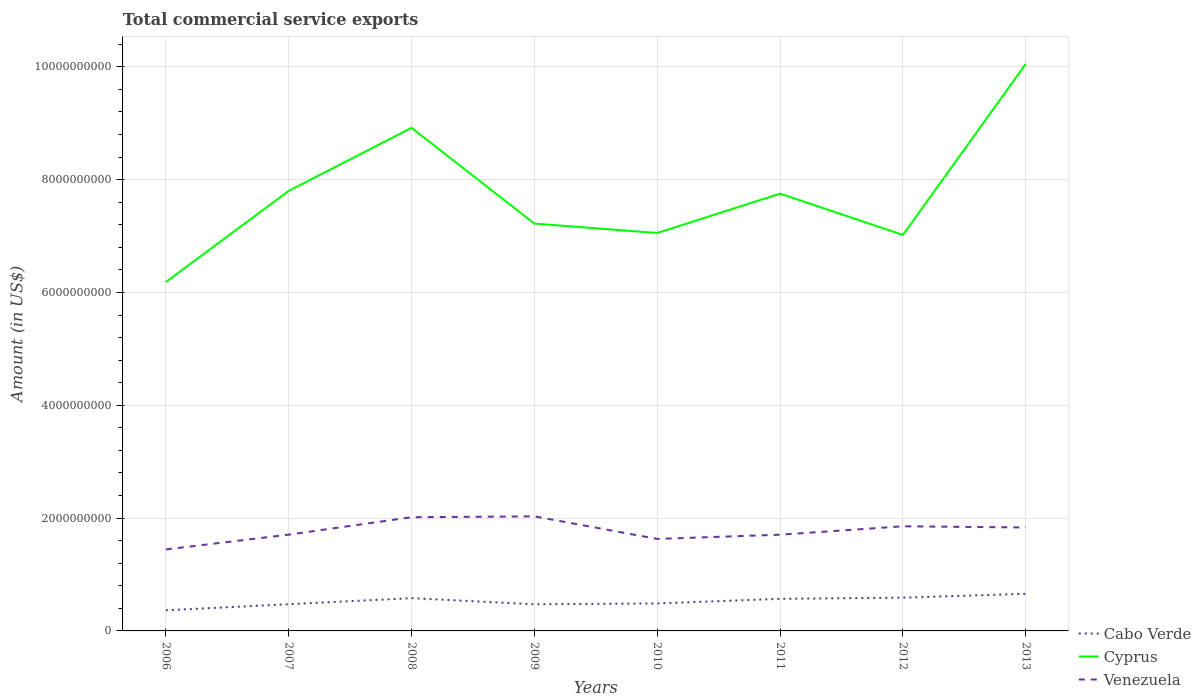Across all years, what is the maximum total commercial service exports in Venezuela?
Your answer should be compact. 1.44e+09. In which year was the total commercial service exports in Venezuela maximum?
Ensure brevity in your answer.  2006. What is the total total commercial service exports in Cabo Verde in the graph?
Your answer should be compact. -6.75e+07. What is the difference between the highest and the second highest total commercial service exports in Venezuela?
Offer a terse response. 5.86e+08. What is the difference between the highest and the lowest total commercial service exports in Cabo Verde?
Keep it short and to the point. 4. How many lines are there?
Make the answer very short. 3. How many years are there in the graph?
Provide a succinct answer. 8. Does the graph contain any zero values?
Your answer should be compact. No. Does the graph contain grids?
Your response must be concise. Yes. How are the legend labels stacked?
Your answer should be very brief. Vertical. What is the title of the graph?
Give a very brief answer. Total commercial service exports. What is the label or title of the Y-axis?
Keep it short and to the point. Amount (in US$). What is the Amount (in US$) in Cabo Verde in 2006?
Your answer should be very brief. 3.66e+08. What is the Amount (in US$) of Cyprus in 2006?
Make the answer very short. 6.19e+09. What is the Amount (in US$) of Venezuela in 2006?
Keep it short and to the point. 1.44e+09. What is the Amount (in US$) of Cabo Verde in 2007?
Your answer should be very brief. 4.74e+08. What is the Amount (in US$) in Cyprus in 2007?
Provide a succinct answer. 7.80e+09. What is the Amount (in US$) in Venezuela in 2007?
Offer a very short reply. 1.71e+09. What is the Amount (in US$) of Cabo Verde in 2008?
Keep it short and to the point. 5.81e+08. What is the Amount (in US$) of Cyprus in 2008?
Your answer should be very brief. 8.92e+09. What is the Amount (in US$) in Venezuela in 2008?
Provide a succinct answer. 2.02e+09. What is the Amount (in US$) in Cabo Verde in 2009?
Provide a short and direct response. 4.72e+08. What is the Amount (in US$) in Cyprus in 2009?
Offer a terse response. 7.22e+09. What is the Amount (in US$) of Venezuela in 2009?
Your answer should be very brief. 2.03e+09. What is the Amount (in US$) of Cabo Verde in 2010?
Provide a succinct answer. 4.87e+08. What is the Amount (in US$) of Cyprus in 2010?
Your response must be concise. 7.05e+09. What is the Amount (in US$) in Venezuela in 2010?
Keep it short and to the point. 1.63e+09. What is the Amount (in US$) of Cabo Verde in 2011?
Ensure brevity in your answer.  5.69e+08. What is the Amount (in US$) in Cyprus in 2011?
Your answer should be compact. 7.75e+09. What is the Amount (in US$) of Venezuela in 2011?
Make the answer very short. 1.71e+09. What is the Amount (in US$) in Cabo Verde in 2012?
Your answer should be compact. 5.90e+08. What is the Amount (in US$) in Cyprus in 2012?
Offer a terse response. 7.02e+09. What is the Amount (in US$) in Venezuela in 2012?
Provide a succinct answer. 1.86e+09. What is the Amount (in US$) in Cabo Verde in 2013?
Your answer should be very brief. 6.58e+08. What is the Amount (in US$) in Cyprus in 2013?
Ensure brevity in your answer.  1.01e+1. What is the Amount (in US$) of Venezuela in 2013?
Your answer should be compact. 1.83e+09. Across all years, what is the maximum Amount (in US$) of Cabo Verde?
Provide a short and direct response. 6.58e+08. Across all years, what is the maximum Amount (in US$) of Cyprus?
Provide a succinct answer. 1.01e+1. Across all years, what is the maximum Amount (in US$) of Venezuela?
Provide a short and direct response. 2.03e+09. Across all years, what is the minimum Amount (in US$) in Cabo Verde?
Offer a terse response. 3.66e+08. Across all years, what is the minimum Amount (in US$) in Cyprus?
Give a very brief answer. 6.19e+09. Across all years, what is the minimum Amount (in US$) of Venezuela?
Give a very brief answer. 1.44e+09. What is the total Amount (in US$) of Cabo Verde in the graph?
Keep it short and to the point. 4.20e+09. What is the total Amount (in US$) of Cyprus in the graph?
Your response must be concise. 6.20e+1. What is the total Amount (in US$) in Venezuela in the graph?
Offer a very short reply. 1.42e+1. What is the difference between the Amount (in US$) in Cabo Verde in 2006 and that in 2007?
Ensure brevity in your answer.  -1.08e+08. What is the difference between the Amount (in US$) of Cyprus in 2006 and that in 2007?
Your answer should be very brief. -1.62e+09. What is the difference between the Amount (in US$) of Venezuela in 2006 and that in 2007?
Keep it short and to the point. -2.62e+08. What is the difference between the Amount (in US$) in Cabo Verde in 2006 and that in 2008?
Offer a very short reply. -2.15e+08. What is the difference between the Amount (in US$) in Cyprus in 2006 and that in 2008?
Your answer should be very brief. -2.73e+09. What is the difference between the Amount (in US$) in Venezuela in 2006 and that in 2008?
Your answer should be very brief. -5.71e+08. What is the difference between the Amount (in US$) of Cabo Verde in 2006 and that in 2009?
Ensure brevity in your answer.  -1.07e+08. What is the difference between the Amount (in US$) in Cyprus in 2006 and that in 2009?
Provide a short and direct response. -1.04e+09. What is the difference between the Amount (in US$) of Venezuela in 2006 and that in 2009?
Your answer should be compact. -5.86e+08. What is the difference between the Amount (in US$) of Cabo Verde in 2006 and that in 2010?
Your answer should be very brief. -1.22e+08. What is the difference between the Amount (in US$) of Cyprus in 2006 and that in 2010?
Your answer should be compact. -8.69e+08. What is the difference between the Amount (in US$) in Venezuela in 2006 and that in 2010?
Ensure brevity in your answer.  -1.86e+08. What is the difference between the Amount (in US$) in Cabo Verde in 2006 and that in 2011?
Offer a very short reply. -2.03e+08. What is the difference between the Amount (in US$) in Cyprus in 2006 and that in 2011?
Keep it short and to the point. -1.57e+09. What is the difference between the Amount (in US$) in Venezuela in 2006 and that in 2011?
Offer a terse response. -2.61e+08. What is the difference between the Amount (in US$) in Cabo Verde in 2006 and that in 2012?
Make the answer very short. -2.24e+08. What is the difference between the Amount (in US$) of Cyprus in 2006 and that in 2012?
Offer a very short reply. -8.35e+08. What is the difference between the Amount (in US$) of Venezuela in 2006 and that in 2012?
Your response must be concise. -4.10e+08. What is the difference between the Amount (in US$) in Cabo Verde in 2006 and that in 2013?
Keep it short and to the point. -2.92e+08. What is the difference between the Amount (in US$) in Cyprus in 2006 and that in 2013?
Make the answer very short. -3.87e+09. What is the difference between the Amount (in US$) in Venezuela in 2006 and that in 2013?
Give a very brief answer. -3.89e+08. What is the difference between the Amount (in US$) in Cabo Verde in 2007 and that in 2008?
Your answer should be compact. -1.07e+08. What is the difference between the Amount (in US$) in Cyprus in 2007 and that in 2008?
Keep it short and to the point. -1.12e+09. What is the difference between the Amount (in US$) in Venezuela in 2007 and that in 2008?
Provide a short and direct response. -3.09e+08. What is the difference between the Amount (in US$) in Cabo Verde in 2007 and that in 2009?
Provide a short and direct response. 1.47e+06. What is the difference between the Amount (in US$) of Cyprus in 2007 and that in 2009?
Provide a succinct answer. 5.80e+08. What is the difference between the Amount (in US$) of Venezuela in 2007 and that in 2009?
Make the answer very short. -3.24e+08. What is the difference between the Amount (in US$) in Cabo Verde in 2007 and that in 2010?
Provide a succinct answer. -1.36e+07. What is the difference between the Amount (in US$) in Cyprus in 2007 and that in 2010?
Ensure brevity in your answer.  7.46e+08. What is the difference between the Amount (in US$) in Venezuela in 2007 and that in 2010?
Make the answer very short. 7.60e+07. What is the difference between the Amount (in US$) of Cabo Verde in 2007 and that in 2011?
Provide a succinct answer. -9.52e+07. What is the difference between the Amount (in US$) of Cyprus in 2007 and that in 2011?
Ensure brevity in your answer.  4.86e+07. What is the difference between the Amount (in US$) of Cabo Verde in 2007 and that in 2012?
Offer a terse response. -1.16e+08. What is the difference between the Amount (in US$) of Cyprus in 2007 and that in 2012?
Keep it short and to the point. 7.81e+08. What is the difference between the Amount (in US$) in Venezuela in 2007 and that in 2012?
Your response must be concise. -1.48e+08. What is the difference between the Amount (in US$) of Cabo Verde in 2007 and that in 2013?
Offer a terse response. -1.84e+08. What is the difference between the Amount (in US$) in Cyprus in 2007 and that in 2013?
Provide a short and direct response. -2.25e+09. What is the difference between the Amount (in US$) in Venezuela in 2007 and that in 2013?
Your response must be concise. -1.27e+08. What is the difference between the Amount (in US$) of Cabo Verde in 2008 and that in 2009?
Your response must be concise. 1.09e+08. What is the difference between the Amount (in US$) in Cyprus in 2008 and that in 2009?
Ensure brevity in your answer.  1.70e+09. What is the difference between the Amount (in US$) in Venezuela in 2008 and that in 2009?
Keep it short and to the point. -1.50e+07. What is the difference between the Amount (in US$) in Cabo Verde in 2008 and that in 2010?
Your response must be concise. 9.37e+07. What is the difference between the Amount (in US$) of Cyprus in 2008 and that in 2010?
Provide a succinct answer. 1.86e+09. What is the difference between the Amount (in US$) of Venezuela in 2008 and that in 2010?
Keep it short and to the point. 3.85e+08. What is the difference between the Amount (in US$) of Cabo Verde in 2008 and that in 2011?
Give a very brief answer. 1.21e+07. What is the difference between the Amount (in US$) in Cyprus in 2008 and that in 2011?
Make the answer very short. 1.17e+09. What is the difference between the Amount (in US$) of Venezuela in 2008 and that in 2011?
Your answer should be compact. 3.10e+08. What is the difference between the Amount (in US$) in Cabo Verde in 2008 and that in 2012?
Ensure brevity in your answer.  -8.97e+06. What is the difference between the Amount (in US$) in Cyprus in 2008 and that in 2012?
Ensure brevity in your answer.  1.90e+09. What is the difference between the Amount (in US$) of Venezuela in 2008 and that in 2012?
Offer a terse response. 1.61e+08. What is the difference between the Amount (in US$) in Cabo Verde in 2008 and that in 2013?
Provide a short and direct response. -7.65e+07. What is the difference between the Amount (in US$) in Cyprus in 2008 and that in 2013?
Give a very brief answer. -1.13e+09. What is the difference between the Amount (in US$) of Venezuela in 2008 and that in 2013?
Your answer should be compact. 1.82e+08. What is the difference between the Amount (in US$) in Cabo Verde in 2009 and that in 2010?
Offer a terse response. -1.51e+07. What is the difference between the Amount (in US$) of Cyprus in 2009 and that in 2010?
Provide a succinct answer. 1.67e+08. What is the difference between the Amount (in US$) in Venezuela in 2009 and that in 2010?
Offer a very short reply. 4.00e+08. What is the difference between the Amount (in US$) of Cabo Verde in 2009 and that in 2011?
Offer a terse response. -9.67e+07. What is the difference between the Amount (in US$) of Cyprus in 2009 and that in 2011?
Provide a short and direct response. -5.31e+08. What is the difference between the Amount (in US$) of Venezuela in 2009 and that in 2011?
Your answer should be compact. 3.25e+08. What is the difference between the Amount (in US$) in Cabo Verde in 2009 and that in 2012?
Your answer should be very brief. -1.18e+08. What is the difference between the Amount (in US$) of Cyprus in 2009 and that in 2012?
Your answer should be very brief. 2.01e+08. What is the difference between the Amount (in US$) of Venezuela in 2009 and that in 2012?
Make the answer very short. 1.76e+08. What is the difference between the Amount (in US$) in Cabo Verde in 2009 and that in 2013?
Provide a succinct answer. -1.85e+08. What is the difference between the Amount (in US$) in Cyprus in 2009 and that in 2013?
Provide a short and direct response. -2.83e+09. What is the difference between the Amount (in US$) of Venezuela in 2009 and that in 2013?
Ensure brevity in your answer.  1.97e+08. What is the difference between the Amount (in US$) in Cabo Verde in 2010 and that in 2011?
Provide a succinct answer. -8.16e+07. What is the difference between the Amount (in US$) of Cyprus in 2010 and that in 2011?
Ensure brevity in your answer.  -6.98e+08. What is the difference between the Amount (in US$) in Venezuela in 2010 and that in 2011?
Provide a succinct answer. -7.50e+07. What is the difference between the Amount (in US$) of Cabo Verde in 2010 and that in 2012?
Keep it short and to the point. -1.03e+08. What is the difference between the Amount (in US$) in Cyprus in 2010 and that in 2012?
Your answer should be compact. 3.44e+07. What is the difference between the Amount (in US$) in Venezuela in 2010 and that in 2012?
Your answer should be very brief. -2.24e+08. What is the difference between the Amount (in US$) in Cabo Verde in 2010 and that in 2013?
Offer a very short reply. -1.70e+08. What is the difference between the Amount (in US$) in Cyprus in 2010 and that in 2013?
Your response must be concise. -3.00e+09. What is the difference between the Amount (in US$) of Venezuela in 2010 and that in 2013?
Make the answer very short. -2.03e+08. What is the difference between the Amount (in US$) of Cabo Verde in 2011 and that in 2012?
Your response must be concise. -2.10e+07. What is the difference between the Amount (in US$) in Cyprus in 2011 and that in 2012?
Your response must be concise. 7.32e+08. What is the difference between the Amount (in US$) of Venezuela in 2011 and that in 2012?
Make the answer very short. -1.49e+08. What is the difference between the Amount (in US$) of Cabo Verde in 2011 and that in 2013?
Make the answer very short. -8.86e+07. What is the difference between the Amount (in US$) in Cyprus in 2011 and that in 2013?
Make the answer very short. -2.30e+09. What is the difference between the Amount (in US$) in Venezuela in 2011 and that in 2013?
Ensure brevity in your answer.  -1.28e+08. What is the difference between the Amount (in US$) in Cabo Verde in 2012 and that in 2013?
Ensure brevity in your answer.  -6.75e+07. What is the difference between the Amount (in US$) in Cyprus in 2012 and that in 2013?
Your response must be concise. -3.03e+09. What is the difference between the Amount (in US$) of Venezuela in 2012 and that in 2013?
Provide a short and direct response. 2.10e+07. What is the difference between the Amount (in US$) of Cabo Verde in 2006 and the Amount (in US$) of Cyprus in 2007?
Give a very brief answer. -7.44e+09. What is the difference between the Amount (in US$) of Cabo Verde in 2006 and the Amount (in US$) of Venezuela in 2007?
Offer a terse response. -1.34e+09. What is the difference between the Amount (in US$) in Cyprus in 2006 and the Amount (in US$) in Venezuela in 2007?
Provide a short and direct response. 4.48e+09. What is the difference between the Amount (in US$) in Cabo Verde in 2006 and the Amount (in US$) in Cyprus in 2008?
Provide a short and direct response. -8.55e+09. What is the difference between the Amount (in US$) in Cabo Verde in 2006 and the Amount (in US$) in Venezuela in 2008?
Offer a terse response. -1.65e+09. What is the difference between the Amount (in US$) of Cyprus in 2006 and the Amount (in US$) of Venezuela in 2008?
Ensure brevity in your answer.  4.17e+09. What is the difference between the Amount (in US$) in Cabo Verde in 2006 and the Amount (in US$) in Cyprus in 2009?
Your response must be concise. -6.86e+09. What is the difference between the Amount (in US$) in Cabo Verde in 2006 and the Amount (in US$) in Venezuela in 2009?
Offer a terse response. -1.67e+09. What is the difference between the Amount (in US$) in Cyprus in 2006 and the Amount (in US$) in Venezuela in 2009?
Ensure brevity in your answer.  4.15e+09. What is the difference between the Amount (in US$) in Cabo Verde in 2006 and the Amount (in US$) in Cyprus in 2010?
Your answer should be compact. -6.69e+09. What is the difference between the Amount (in US$) in Cabo Verde in 2006 and the Amount (in US$) in Venezuela in 2010?
Give a very brief answer. -1.27e+09. What is the difference between the Amount (in US$) of Cyprus in 2006 and the Amount (in US$) of Venezuela in 2010?
Provide a short and direct response. 4.55e+09. What is the difference between the Amount (in US$) in Cabo Verde in 2006 and the Amount (in US$) in Cyprus in 2011?
Offer a very short reply. -7.39e+09. What is the difference between the Amount (in US$) of Cabo Verde in 2006 and the Amount (in US$) of Venezuela in 2011?
Ensure brevity in your answer.  -1.34e+09. What is the difference between the Amount (in US$) in Cyprus in 2006 and the Amount (in US$) in Venezuela in 2011?
Make the answer very short. 4.48e+09. What is the difference between the Amount (in US$) of Cabo Verde in 2006 and the Amount (in US$) of Cyprus in 2012?
Ensure brevity in your answer.  -6.66e+09. What is the difference between the Amount (in US$) in Cabo Verde in 2006 and the Amount (in US$) in Venezuela in 2012?
Offer a very short reply. -1.49e+09. What is the difference between the Amount (in US$) of Cyprus in 2006 and the Amount (in US$) of Venezuela in 2012?
Make the answer very short. 4.33e+09. What is the difference between the Amount (in US$) of Cabo Verde in 2006 and the Amount (in US$) of Cyprus in 2013?
Offer a terse response. -9.69e+09. What is the difference between the Amount (in US$) of Cabo Verde in 2006 and the Amount (in US$) of Venezuela in 2013?
Your answer should be compact. -1.47e+09. What is the difference between the Amount (in US$) of Cyprus in 2006 and the Amount (in US$) of Venezuela in 2013?
Make the answer very short. 4.35e+09. What is the difference between the Amount (in US$) of Cabo Verde in 2007 and the Amount (in US$) of Cyprus in 2008?
Your answer should be very brief. -8.45e+09. What is the difference between the Amount (in US$) of Cabo Verde in 2007 and the Amount (in US$) of Venezuela in 2008?
Make the answer very short. -1.54e+09. What is the difference between the Amount (in US$) in Cyprus in 2007 and the Amount (in US$) in Venezuela in 2008?
Offer a very short reply. 5.79e+09. What is the difference between the Amount (in US$) in Cabo Verde in 2007 and the Amount (in US$) in Cyprus in 2009?
Your response must be concise. -6.75e+09. What is the difference between the Amount (in US$) of Cabo Verde in 2007 and the Amount (in US$) of Venezuela in 2009?
Make the answer very short. -1.56e+09. What is the difference between the Amount (in US$) in Cyprus in 2007 and the Amount (in US$) in Venezuela in 2009?
Offer a terse response. 5.77e+09. What is the difference between the Amount (in US$) in Cabo Verde in 2007 and the Amount (in US$) in Cyprus in 2010?
Your response must be concise. -6.58e+09. What is the difference between the Amount (in US$) of Cabo Verde in 2007 and the Amount (in US$) of Venezuela in 2010?
Keep it short and to the point. -1.16e+09. What is the difference between the Amount (in US$) of Cyprus in 2007 and the Amount (in US$) of Venezuela in 2010?
Keep it short and to the point. 6.17e+09. What is the difference between the Amount (in US$) of Cabo Verde in 2007 and the Amount (in US$) of Cyprus in 2011?
Your answer should be compact. -7.28e+09. What is the difference between the Amount (in US$) of Cabo Verde in 2007 and the Amount (in US$) of Venezuela in 2011?
Ensure brevity in your answer.  -1.23e+09. What is the difference between the Amount (in US$) in Cyprus in 2007 and the Amount (in US$) in Venezuela in 2011?
Give a very brief answer. 6.10e+09. What is the difference between the Amount (in US$) of Cabo Verde in 2007 and the Amount (in US$) of Cyprus in 2012?
Keep it short and to the point. -6.55e+09. What is the difference between the Amount (in US$) of Cabo Verde in 2007 and the Amount (in US$) of Venezuela in 2012?
Your answer should be very brief. -1.38e+09. What is the difference between the Amount (in US$) in Cyprus in 2007 and the Amount (in US$) in Venezuela in 2012?
Your answer should be compact. 5.95e+09. What is the difference between the Amount (in US$) of Cabo Verde in 2007 and the Amount (in US$) of Cyprus in 2013?
Offer a terse response. -9.58e+09. What is the difference between the Amount (in US$) of Cabo Verde in 2007 and the Amount (in US$) of Venezuela in 2013?
Offer a very short reply. -1.36e+09. What is the difference between the Amount (in US$) in Cyprus in 2007 and the Amount (in US$) in Venezuela in 2013?
Your response must be concise. 5.97e+09. What is the difference between the Amount (in US$) of Cabo Verde in 2008 and the Amount (in US$) of Cyprus in 2009?
Offer a very short reply. -6.64e+09. What is the difference between the Amount (in US$) of Cabo Verde in 2008 and the Amount (in US$) of Venezuela in 2009?
Keep it short and to the point. -1.45e+09. What is the difference between the Amount (in US$) in Cyprus in 2008 and the Amount (in US$) in Venezuela in 2009?
Offer a terse response. 6.89e+09. What is the difference between the Amount (in US$) of Cabo Verde in 2008 and the Amount (in US$) of Cyprus in 2010?
Provide a short and direct response. -6.47e+09. What is the difference between the Amount (in US$) of Cabo Verde in 2008 and the Amount (in US$) of Venezuela in 2010?
Your answer should be compact. -1.05e+09. What is the difference between the Amount (in US$) of Cyprus in 2008 and the Amount (in US$) of Venezuela in 2010?
Offer a terse response. 7.29e+09. What is the difference between the Amount (in US$) of Cabo Verde in 2008 and the Amount (in US$) of Cyprus in 2011?
Offer a very short reply. -7.17e+09. What is the difference between the Amount (in US$) of Cabo Verde in 2008 and the Amount (in US$) of Venezuela in 2011?
Provide a succinct answer. -1.12e+09. What is the difference between the Amount (in US$) of Cyprus in 2008 and the Amount (in US$) of Venezuela in 2011?
Offer a terse response. 7.21e+09. What is the difference between the Amount (in US$) in Cabo Verde in 2008 and the Amount (in US$) in Cyprus in 2012?
Ensure brevity in your answer.  -6.44e+09. What is the difference between the Amount (in US$) in Cabo Verde in 2008 and the Amount (in US$) in Venezuela in 2012?
Ensure brevity in your answer.  -1.27e+09. What is the difference between the Amount (in US$) of Cyprus in 2008 and the Amount (in US$) of Venezuela in 2012?
Ensure brevity in your answer.  7.06e+09. What is the difference between the Amount (in US$) of Cabo Verde in 2008 and the Amount (in US$) of Cyprus in 2013?
Keep it short and to the point. -9.47e+09. What is the difference between the Amount (in US$) in Cabo Verde in 2008 and the Amount (in US$) in Venezuela in 2013?
Make the answer very short. -1.25e+09. What is the difference between the Amount (in US$) in Cyprus in 2008 and the Amount (in US$) in Venezuela in 2013?
Provide a short and direct response. 7.08e+09. What is the difference between the Amount (in US$) in Cabo Verde in 2009 and the Amount (in US$) in Cyprus in 2010?
Ensure brevity in your answer.  -6.58e+09. What is the difference between the Amount (in US$) of Cabo Verde in 2009 and the Amount (in US$) of Venezuela in 2010?
Your answer should be compact. -1.16e+09. What is the difference between the Amount (in US$) of Cyprus in 2009 and the Amount (in US$) of Venezuela in 2010?
Your response must be concise. 5.59e+09. What is the difference between the Amount (in US$) of Cabo Verde in 2009 and the Amount (in US$) of Cyprus in 2011?
Your answer should be very brief. -7.28e+09. What is the difference between the Amount (in US$) in Cabo Verde in 2009 and the Amount (in US$) in Venezuela in 2011?
Provide a succinct answer. -1.23e+09. What is the difference between the Amount (in US$) in Cyprus in 2009 and the Amount (in US$) in Venezuela in 2011?
Your answer should be compact. 5.52e+09. What is the difference between the Amount (in US$) of Cabo Verde in 2009 and the Amount (in US$) of Cyprus in 2012?
Ensure brevity in your answer.  -6.55e+09. What is the difference between the Amount (in US$) in Cabo Verde in 2009 and the Amount (in US$) in Venezuela in 2012?
Make the answer very short. -1.38e+09. What is the difference between the Amount (in US$) in Cyprus in 2009 and the Amount (in US$) in Venezuela in 2012?
Your answer should be very brief. 5.37e+09. What is the difference between the Amount (in US$) of Cabo Verde in 2009 and the Amount (in US$) of Cyprus in 2013?
Ensure brevity in your answer.  -9.58e+09. What is the difference between the Amount (in US$) in Cabo Verde in 2009 and the Amount (in US$) in Venezuela in 2013?
Your response must be concise. -1.36e+09. What is the difference between the Amount (in US$) of Cyprus in 2009 and the Amount (in US$) of Venezuela in 2013?
Give a very brief answer. 5.39e+09. What is the difference between the Amount (in US$) of Cabo Verde in 2010 and the Amount (in US$) of Cyprus in 2011?
Your answer should be very brief. -7.27e+09. What is the difference between the Amount (in US$) of Cabo Verde in 2010 and the Amount (in US$) of Venezuela in 2011?
Your response must be concise. -1.22e+09. What is the difference between the Amount (in US$) in Cyprus in 2010 and the Amount (in US$) in Venezuela in 2011?
Make the answer very short. 5.35e+09. What is the difference between the Amount (in US$) in Cabo Verde in 2010 and the Amount (in US$) in Cyprus in 2012?
Offer a very short reply. -6.53e+09. What is the difference between the Amount (in US$) in Cabo Verde in 2010 and the Amount (in US$) in Venezuela in 2012?
Provide a succinct answer. -1.37e+09. What is the difference between the Amount (in US$) in Cyprus in 2010 and the Amount (in US$) in Venezuela in 2012?
Give a very brief answer. 5.20e+09. What is the difference between the Amount (in US$) in Cabo Verde in 2010 and the Amount (in US$) in Cyprus in 2013?
Offer a terse response. -9.57e+09. What is the difference between the Amount (in US$) of Cabo Verde in 2010 and the Amount (in US$) of Venezuela in 2013?
Offer a very short reply. -1.35e+09. What is the difference between the Amount (in US$) in Cyprus in 2010 and the Amount (in US$) in Venezuela in 2013?
Give a very brief answer. 5.22e+09. What is the difference between the Amount (in US$) in Cabo Verde in 2011 and the Amount (in US$) in Cyprus in 2012?
Give a very brief answer. -6.45e+09. What is the difference between the Amount (in US$) of Cabo Verde in 2011 and the Amount (in US$) of Venezuela in 2012?
Ensure brevity in your answer.  -1.29e+09. What is the difference between the Amount (in US$) of Cyprus in 2011 and the Amount (in US$) of Venezuela in 2012?
Make the answer very short. 5.90e+09. What is the difference between the Amount (in US$) of Cabo Verde in 2011 and the Amount (in US$) of Cyprus in 2013?
Your response must be concise. -9.48e+09. What is the difference between the Amount (in US$) of Cabo Verde in 2011 and the Amount (in US$) of Venezuela in 2013?
Make the answer very short. -1.27e+09. What is the difference between the Amount (in US$) of Cyprus in 2011 and the Amount (in US$) of Venezuela in 2013?
Ensure brevity in your answer.  5.92e+09. What is the difference between the Amount (in US$) in Cabo Verde in 2012 and the Amount (in US$) in Cyprus in 2013?
Provide a succinct answer. -9.46e+09. What is the difference between the Amount (in US$) in Cabo Verde in 2012 and the Amount (in US$) in Venezuela in 2013?
Ensure brevity in your answer.  -1.24e+09. What is the difference between the Amount (in US$) of Cyprus in 2012 and the Amount (in US$) of Venezuela in 2013?
Provide a succinct answer. 5.19e+09. What is the average Amount (in US$) of Cabo Verde per year?
Provide a short and direct response. 5.25e+08. What is the average Amount (in US$) of Cyprus per year?
Your answer should be very brief. 7.75e+09. What is the average Amount (in US$) in Venezuela per year?
Make the answer very short. 1.78e+09. In the year 2006, what is the difference between the Amount (in US$) of Cabo Verde and Amount (in US$) of Cyprus?
Ensure brevity in your answer.  -5.82e+09. In the year 2006, what is the difference between the Amount (in US$) in Cabo Verde and Amount (in US$) in Venezuela?
Your answer should be compact. -1.08e+09. In the year 2006, what is the difference between the Amount (in US$) of Cyprus and Amount (in US$) of Venezuela?
Your answer should be very brief. 4.74e+09. In the year 2007, what is the difference between the Amount (in US$) of Cabo Verde and Amount (in US$) of Cyprus?
Ensure brevity in your answer.  -7.33e+09. In the year 2007, what is the difference between the Amount (in US$) in Cabo Verde and Amount (in US$) in Venezuela?
Make the answer very short. -1.23e+09. In the year 2007, what is the difference between the Amount (in US$) in Cyprus and Amount (in US$) in Venezuela?
Your answer should be compact. 6.09e+09. In the year 2008, what is the difference between the Amount (in US$) in Cabo Verde and Amount (in US$) in Cyprus?
Make the answer very short. -8.34e+09. In the year 2008, what is the difference between the Amount (in US$) in Cabo Verde and Amount (in US$) in Venezuela?
Provide a succinct answer. -1.43e+09. In the year 2008, what is the difference between the Amount (in US$) in Cyprus and Amount (in US$) in Venezuela?
Provide a short and direct response. 6.90e+09. In the year 2009, what is the difference between the Amount (in US$) of Cabo Verde and Amount (in US$) of Cyprus?
Your answer should be very brief. -6.75e+09. In the year 2009, what is the difference between the Amount (in US$) in Cabo Verde and Amount (in US$) in Venezuela?
Your response must be concise. -1.56e+09. In the year 2009, what is the difference between the Amount (in US$) in Cyprus and Amount (in US$) in Venezuela?
Provide a short and direct response. 5.19e+09. In the year 2010, what is the difference between the Amount (in US$) in Cabo Verde and Amount (in US$) in Cyprus?
Provide a short and direct response. -6.57e+09. In the year 2010, what is the difference between the Amount (in US$) of Cabo Verde and Amount (in US$) of Venezuela?
Your response must be concise. -1.14e+09. In the year 2010, what is the difference between the Amount (in US$) in Cyprus and Amount (in US$) in Venezuela?
Keep it short and to the point. 5.42e+09. In the year 2011, what is the difference between the Amount (in US$) in Cabo Verde and Amount (in US$) in Cyprus?
Keep it short and to the point. -7.18e+09. In the year 2011, what is the difference between the Amount (in US$) in Cabo Verde and Amount (in US$) in Venezuela?
Offer a terse response. -1.14e+09. In the year 2011, what is the difference between the Amount (in US$) in Cyprus and Amount (in US$) in Venezuela?
Make the answer very short. 6.05e+09. In the year 2012, what is the difference between the Amount (in US$) of Cabo Verde and Amount (in US$) of Cyprus?
Provide a short and direct response. -6.43e+09. In the year 2012, what is the difference between the Amount (in US$) of Cabo Verde and Amount (in US$) of Venezuela?
Keep it short and to the point. -1.27e+09. In the year 2012, what is the difference between the Amount (in US$) in Cyprus and Amount (in US$) in Venezuela?
Your response must be concise. 5.17e+09. In the year 2013, what is the difference between the Amount (in US$) of Cabo Verde and Amount (in US$) of Cyprus?
Keep it short and to the point. -9.40e+09. In the year 2013, what is the difference between the Amount (in US$) of Cabo Verde and Amount (in US$) of Venezuela?
Provide a succinct answer. -1.18e+09. In the year 2013, what is the difference between the Amount (in US$) of Cyprus and Amount (in US$) of Venezuela?
Make the answer very short. 8.22e+09. What is the ratio of the Amount (in US$) of Cabo Verde in 2006 to that in 2007?
Keep it short and to the point. 0.77. What is the ratio of the Amount (in US$) in Cyprus in 2006 to that in 2007?
Offer a terse response. 0.79. What is the ratio of the Amount (in US$) of Venezuela in 2006 to that in 2007?
Your answer should be compact. 0.85. What is the ratio of the Amount (in US$) in Cabo Verde in 2006 to that in 2008?
Your answer should be compact. 0.63. What is the ratio of the Amount (in US$) in Cyprus in 2006 to that in 2008?
Make the answer very short. 0.69. What is the ratio of the Amount (in US$) of Venezuela in 2006 to that in 2008?
Offer a very short reply. 0.72. What is the ratio of the Amount (in US$) in Cabo Verde in 2006 to that in 2009?
Provide a short and direct response. 0.77. What is the ratio of the Amount (in US$) in Cyprus in 2006 to that in 2009?
Your response must be concise. 0.86. What is the ratio of the Amount (in US$) in Venezuela in 2006 to that in 2009?
Offer a terse response. 0.71. What is the ratio of the Amount (in US$) in Cabo Verde in 2006 to that in 2010?
Offer a terse response. 0.75. What is the ratio of the Amount (in US$) of Cyprus in 2006 to that in 2010?
Provide a short and direct response. 0.88. What is the ratio of the Amount (in US$) of Venezuela in 2006 to that in 2010?
Offer a very short reply. 0.89. What is the ratio of the Amount (in US$) in Cabo Verde in 2006 to that in 2011?
Keep it short and to the point. 0.64. What is the ratio of the Amount (in US$) in Cyprus in 2006 to that in 2011?
Your answer should be compact. 0.8. What is the ratio of the Amount (in US$) of Venezuela in 2006 to that in 2011?
Your answer should be compact. 0.85. What is the ratio of the Amount (in US$) in Cabo Verde in 2006 to that in 2012?
Your answer should be very brief. 0.62. What is the ratio of the Amount (in US$) of Cyprus in 2006 to that in 2012?
Offer a very short reply. 0.88. What is the ratio of the Amount (in US$) in Venezuela in 2006 to that in 2012?
Keep it short and to the point. 0.78. What is the ratio of the Amount (in US$) in Cabo Verde in 2006 to that in 2013?
Your response must be concise. 0.56. What is the ratio of the Amount (in US$) in Cyprus in 2006 to that in 2013?
Provide a succinct answer. 0.62. What is the ratio of the Amount (in US$) of Venezuela in 2006 to that in 2013?
Offer a very short reply. 0.79. What is the ratio of the Amount (in US$) of Cabo Verde in 2007 to that in 2008?
Ensure brevity in your answer.  0.82. What is the ratio of the Amount (in US$) in Cyprus in 2007 to that in 2008?
Offer a terse response. 0.87. What is the ratio of the Amount (in US$) in Venezuela in 2007 to that in 2008?
Offer a very short reply. 0.85. What is the ratio of the Amount (in US$) in Cabo Verde in 2007 to that in 2009?
Your answer should be compact. 1. What is the ratio of the Amount (in US$) in Cyprus in 2007 to that in 2009?
Keep it short and to the point. 1.08. What is the ratio of the Amount (in US$) in Venezuela in 2007 to that in 2009?
Your answer should be very brief. 0.84. What is the ratio of the Amount (in US$) in Cabo Verde in 2007 to that in 2010?
Your answer should be compact. 0.97. What is the ratio of the Amount (in US$) in Cyprus in 2007 to that in 2010?
Offer a terse response. 1.11. What is the ratio of the Amount (in US$) of Venezuela in 2007 to that in 2010?
Give a very brief answer. 1.05. What is the ratio of the Amount (in US$) of Cabo Verde in 2007 to that in 2011?
Give a very brief answer. 0.83. What is the ratio of the Amount (in US$) in Venezuela in 2007 to that in 2011?
Offer a terse response. 1. What is the ratio of the Amount (in US$) in Cabo Verde in 2007 to that in 2012?
Your answer should be compact. 0.8. What is the ratio of the Amount (in US$) of Cyprus in 2007 to that in 2012?
Provide a succinct answer. 1.11. What is the ratio of the Amount (in US$) of Venezuela in 2007 to that in 2012?
Ensure brevity in your answer.  0.92. What is the ratio of the Amount (in US$) in Cabo Verde in 2007 to that in 2013?
Provide a short and direct response. 0.72. What is the ratio of the Amount (in US$) in Cyprus in 2007 to that in 2013?
Offer a terse response. 0.78. What is the ratio of the Amount (in US$) in Venezuela in 2007 to that in 2013?
Provide a succinct answer. 0.93. What is the ratio of the Amount (in US$) of Cabo Verde in 2008 to that in 2009?
Your answer should be very brief. 1.23. What is the ratio of the Amount (in US$) in Cyprus in 2008 to that in 2009?
Your answer should be compact. 1.24. What is the ratio of the Amount (in US$) in Venezuela in 2008 to that in 2009?
Offer a terse response. 0.99. What is the ratio of the Amount (in US$) in Cabo Verde in 2008 to that in 2010?
Your answer should be compact. 1.19. What is the ratio of the Amount (in US$) of Cyprus in 2008 to that in 2010?
Offer a very short reply. 1.26. What is the ratio of the Amount (in US$) in Venezuela in 2008 to that in 2010?
Offer a very short reply. 1.24. What is the ratio of the Amount (in US$) of Cabo Verde in 2008 to that in 2011?
Give a very brief answer. 1.02. What is the ratio of the Amount (in US$) of Cyprus in 2008 to that in 2011?
Your answer should be very brief. 1.15. What is the ratio of the Amount (in US$) in Venezuela in 2008 to that in 2011?
Offer a very short reply. 1.18. What is the ratio of the Amount (in US$) of Cabo Verde in 2008 to that in 2012?
Provide a short and direct response. 0.98. What is the ratio of the Amount (in US$) of Cyprus in 2008 to that in 2012?
Keep it short and to the point. 1.27. What is the ratio of the Amount (in US$) in Venezuela in 2008 to that in 2012?
Give a very brief answer. 1.09. What is the ratio of the Amount (in US$) of Cabo Verde in 2008 to that in 2013?
Keep it short and to the point. 0.88. What is the ratio of the Amount (in US$) of Cyprus in 2008 to that in 2013?
Offer a terse response. 0.89. What is the ratio of the Amount (in US$) in Venezuela in 2008 to that in 2013?
Keep it short and to the point. 1.1. What is the ratio of the Amount (in US$) of Cyprus in 2009 to that in 2010?
Provide a succinct answer. 1.02. What is the ratio of the Amount (in US$) in Venezuela in 2009 to that in 2010?
Your answer should be very brief. 1.25. What is the ratio of the Amount (in US$) in Cabo Verde in 2009 to that in 2011?
Provide a succinct answer. 0.83. What is the ratio of the Amount (in US$) in Cyprus in 2009 to that in 2011?
Make the answer very short. 0.93. What is the ratio of the Amount (in US$) of Venezuela in 2009 to that in 2011?
Your answer should be very brief. 1.19. What is the ratio of the Amount (in US$) in Cabo Verde in 2009 to that in 2012?
Offer a very short reply. 0.8. What is the ratio of the Amount (in US$) of Cyprus in 2009 to that in 2012?
Offer a very short reply. 1.03. What is the ratio of the Amount (in US$) in Venezuela in 2009 to that in 2012?
Provide a short and direct response. 1.09. What is the ratio of the Amount (in US$) of Cabo Verde in 2009 to that in 2013?
Make the answer very short. 0.72. What is the ratio of the Amount (in US$) in Cyprus in 2009 to that in 2013?
Your response must be concise. 0.72. What is the ratio of the Amount (in US$) of Venezuela in 2009 to that in 2013?
Offer a terse response. 1.11. What is the ratio of the Amount (in US$) in Cabo Verde in 2010 to that in 2011?
Keep it short and to the point. 0.86. What is the ratio of the Amount (in US$) of Cyprus in 2010 to that in 2011?
Offer a very short reply. 0.91. What is the ratio of the Amount (in US$) of Venezuela in 2010 to that in 2011?
Ensure brevity in your answer.  0.96. What is the ratio of the Amount (in US$) in Cabo Verde in 2010 to that in 2012?
Your answer should be very brief. 0.83. What is the ratio of the Amount (in US$) in Cyprus in 2010 to that in 2012?
Keep it short and to the point. 1. What is the ratio of the Amount (in US$) of Venezuela in 2010 to that in 2012?
Your answer should be very brief. 0.88. What is the ratio of the Amount (in US$) of Cabo Verde in 2010 to that in 2013?
Make the answer very short. 0.74. What is the ratio of the Amount (in US$) of Cyprus in 2010 to that in 2013?
Your answer should be compact. 0.7. What is the ratio of the Amount (in US$) of Venezuela in 2010 to that in 2013?
Keep it short and to the point. 0.89. What is the ratio of the Amount (in US$) in Cabo Verde in 2011 to that in 2012?
Provide a short and direct response. 0.96. What is the ratio of the Amount (in US$) in Cyprus in 2011 to that in 2012?
Provide a succinct answer. 1.1. What is the ratio of the Amount (in US$) in Venezuela in 2011 to that in 2012?
Make the answer very short. 0.92. What is the ratio of the Amount (in US$) of Cabo Verde in 2011 to that in 2013?
Provide a short and direct response. 0.87. What is the ratio of the Amount (in US$) of Cyprus in 2011 to that in 2013?
Ensure brevity in your answer.  0.77. What is the ratio of the Amount (in US$) of Venezuela in 2011 to that in 2013?
Provide a short and direct response. 0.93. What is the ratio of the Amount (in US$) of Cabo Verde in 2012 to that in 2013?
Provide a short and direct response. 0.9. What is the ratio of the Amount (in US$) in Cyprus in 2012 to that in 2013?
Ensure brevity in your answer.  0.7. What is the ratio of the Amount (in US$) in Venezuela in 2012 to that in 2013?
Keep it short and to the point. 1.01. What is the difference between the highest and the second highest Amount (in US$) in Cabo Verde?
Offer a very short reply. 6.75e+07. What is the difference between the highest and the second highest Amount (in US$) of Cyprus?
Your answer should be very brief. 1.13e+09. What is the difference between the highest and the second highest Amount (in US$) in Venezuela?
Provide a short and direct response. 1.50e+07. What is the difference between the highest and the lowest Amount (in US$) in Cabo Verde?
Provide a short and direct response. 2.92e+08. What is the difference between the highest and the lowest Amount (in US$) in Cyprus?
Provide a succinct answer. 3.87e+09. What is the difference between the highest and the lowest Amount (in US$) of Venezuela?
Provide a short and direct response. 5.86e+08. 